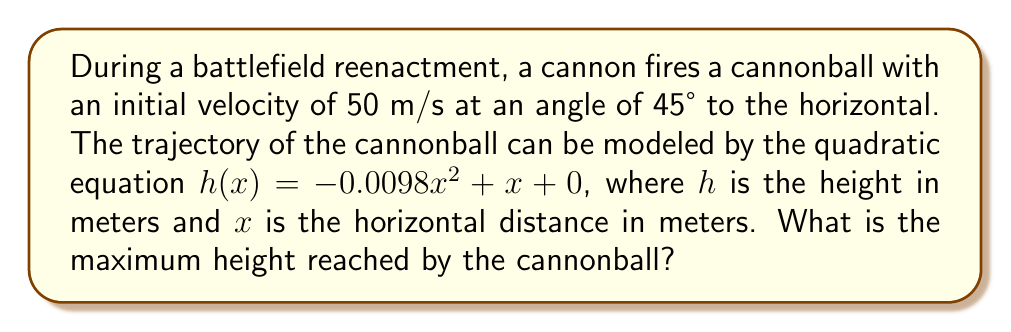What is the answer to this math problem? To find the maximum height of the cannonball's trajectory, we need to follow these steps:

1) The quadratic equation given is in the form $h(x) = ax^2 + bx + c$, where:
   $a = -0.0098$
   $b = 1$
   $c = 0$

2) For a quadratic function, the x-coordinate of the vertex represents the point where the cannonball reaches its maximum height. We can find this using the formula:

   $x = -\frac{b}{2a}$

3) Substituting our values:

   $x = -\frac{1}{2(-0.0098)} = \frac{1}{0.0196} = 51.02$ meters

4) To find the maximum height, we need to plug this x-value back into our original equation:

   $h(51.02) = -0.0098(51.02)^2 + 51.02 + 0$

5) Calculating:
   
   $h(51.02) = -0.0098(2603.04) + 51.02$
              $= -25.51 + 51.02$
              $= 25.51$ meters

Therefore, the maximum height reached by the cannonball is 25.51 meters.
Answer: 25.51 meters 